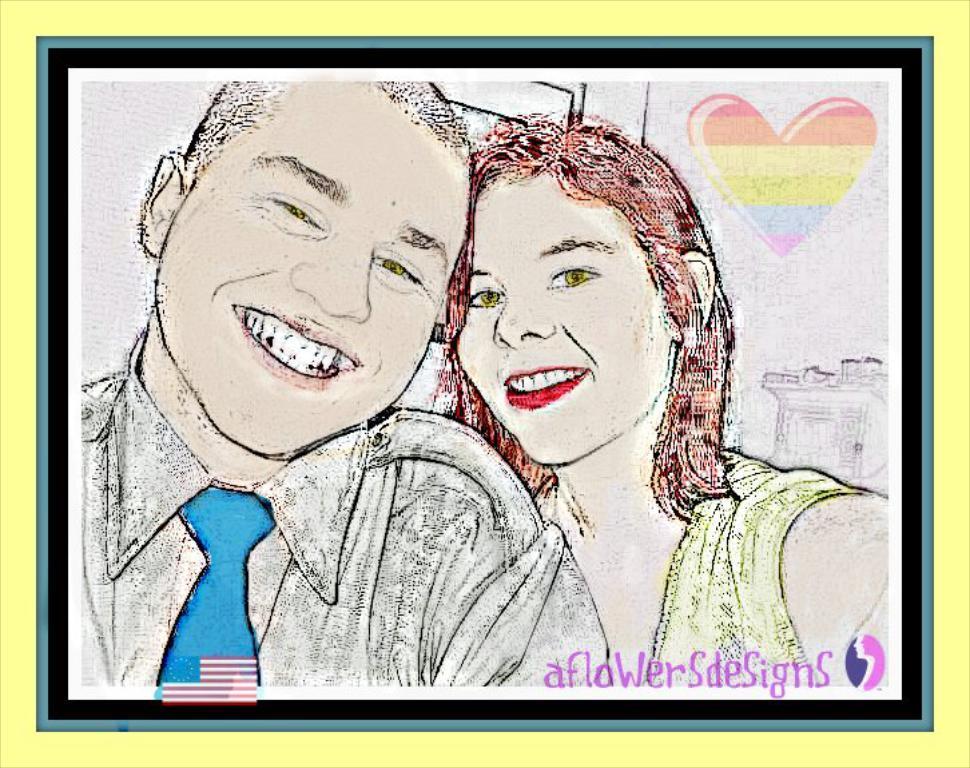Please provide a concise description of this image. This is a sketch painting where we can see a man and a woman having smile on their faces. In the background, there is a heart sticker is present on it. 